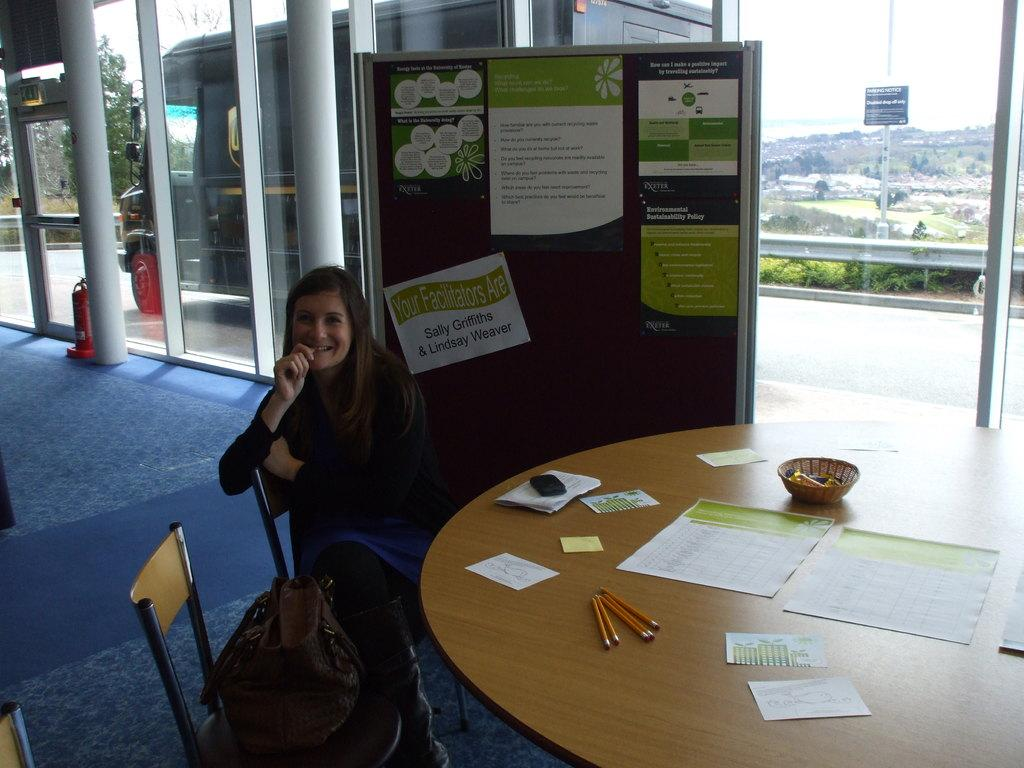What is the woman in the image doing? The woman is sitting on a chair and laughing. Is there another chair in the image? Yes, there is another chair in the image. What is on the chair? There is a bag on the chair. What is in front of the woman? There is a table in front of the woman. What can be seen on the table? There are many things on the table. What is the condition of the sky in the image? The sky is clear and visible in the image. What is the queen doing in the image? There is no queen present in the image; it features a woman sitting on a chair and laughing. How many ducks are visible in the image? There are no ducks present in the image. 